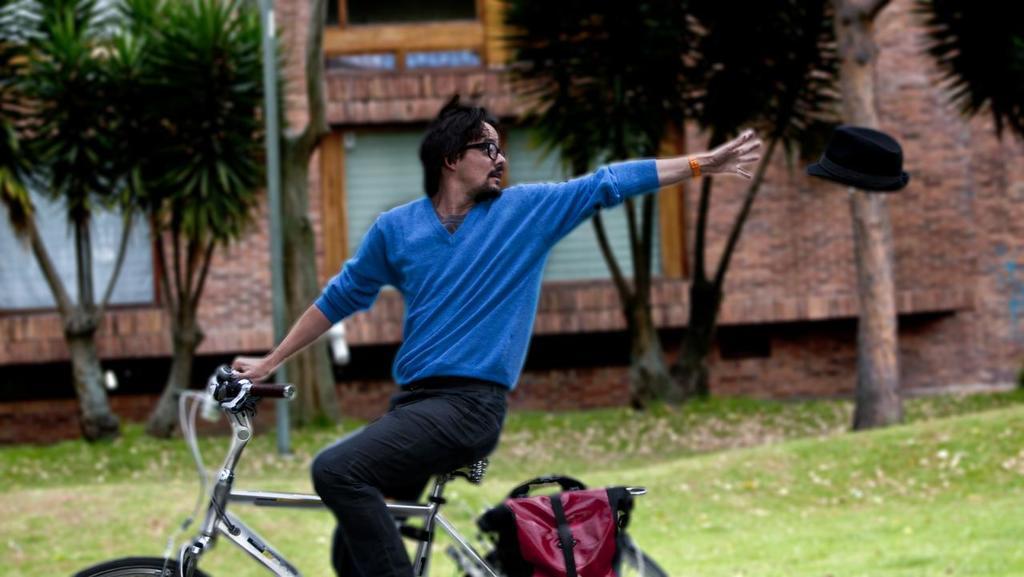Describe this image in one or two sentences. In this image i can see a man riding bi-cycle, he is wearing blue shirt and black pant, there is a bag. At background i can see a tree, a building and the bag is in maroon color. 